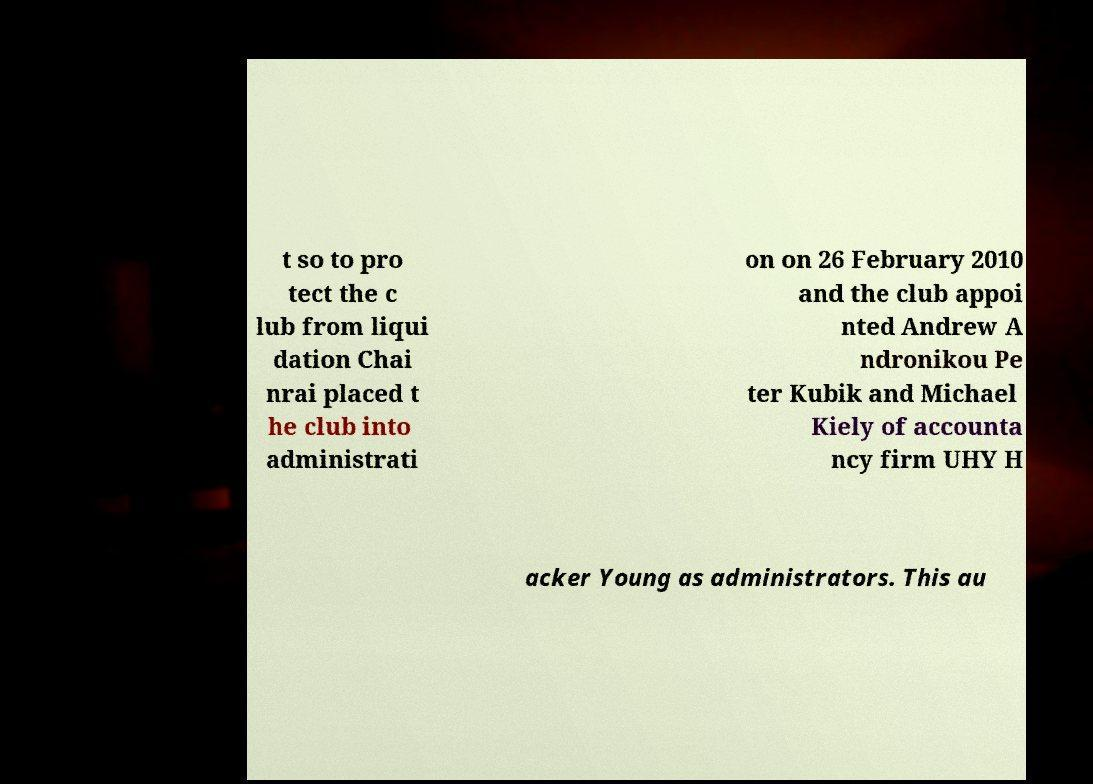Could you extract and type out the text from this image? t so to pro tect the c lub from liqui dation Chai nrai placed t he club into administrati on on 26 February 2010 and the club appoi nted Andrew A ndronikou Pe ter Kubik and Michael Kiely of accounta ncy firm UHY H acker Young as administrators. This au 